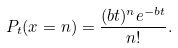<formula> <loc_0><loc_0><loc_500><loc_500>P _ { t } ( x = n ) = \frac { ( b t ) ^ { n } e ^ { - b t } } { n ! } .</formula> 